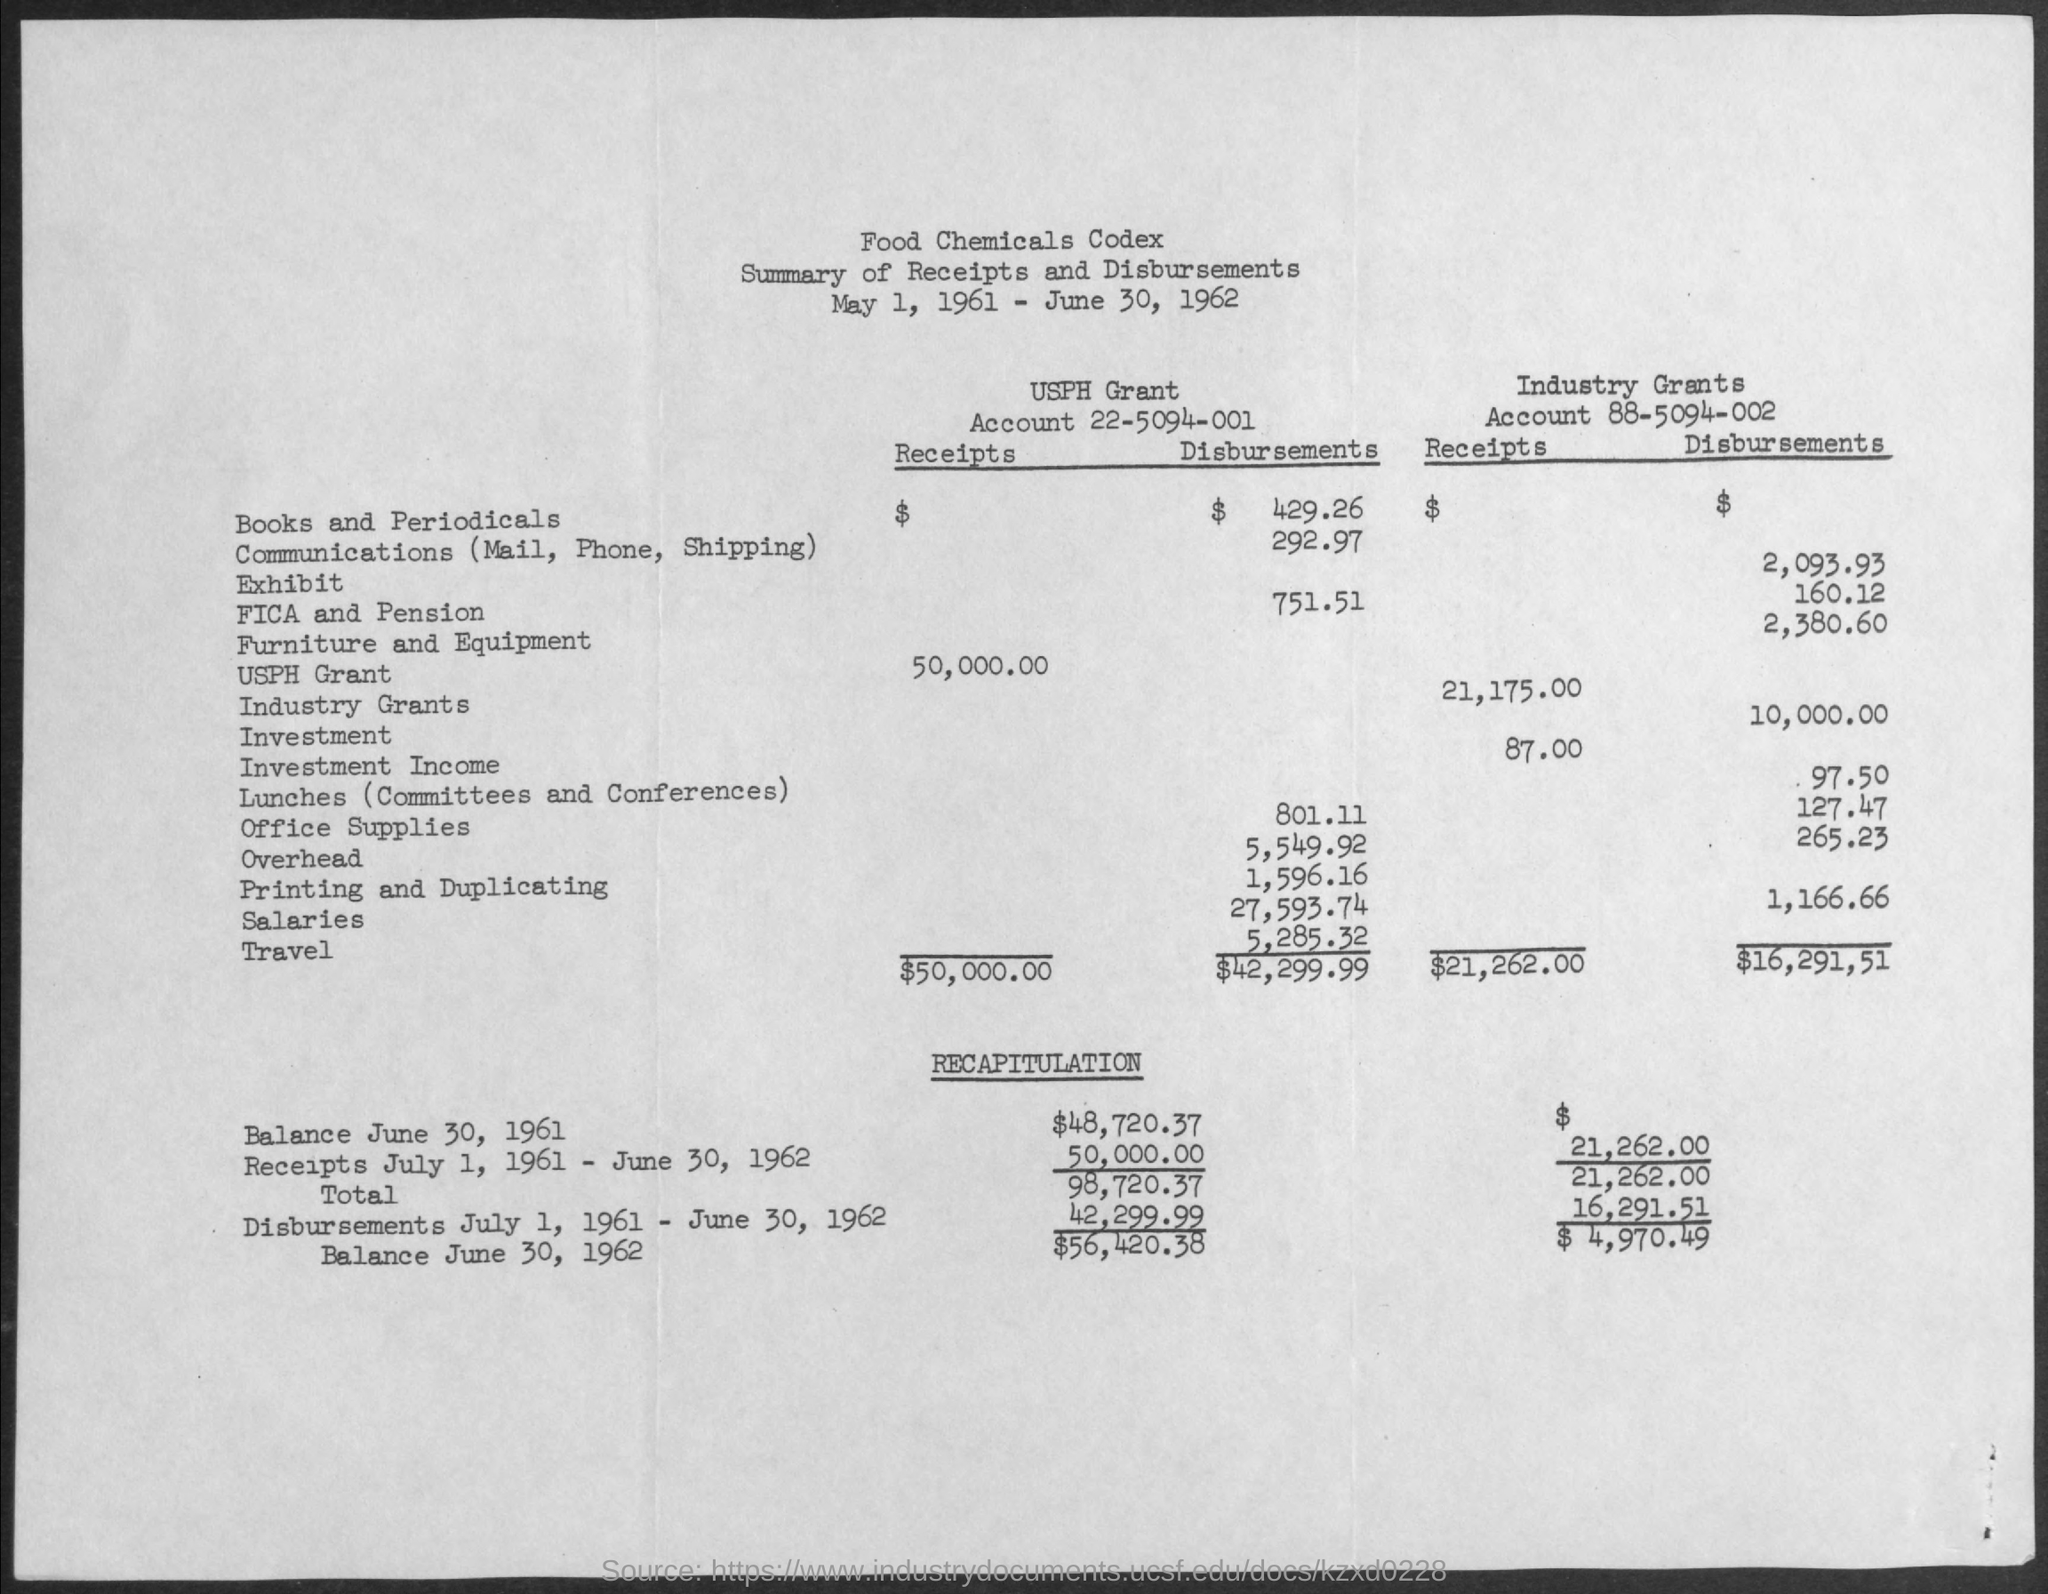What is the date mentioned in the top of the document ?
Your answer should be compact. May 1, 1961 - June 30, 1962. What is the Industry Grants Account Number ?
Your response must be concise. 88-5094-002. What is the USPH Grant Account Number ?
Offer a terse response. 22-5094-001. 